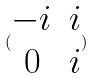<formula> <loc_0><loc_0><loc_500><loc_500>( \begin{matrix} - i & i \\ 0 & i \end{matrix} )</formula> 